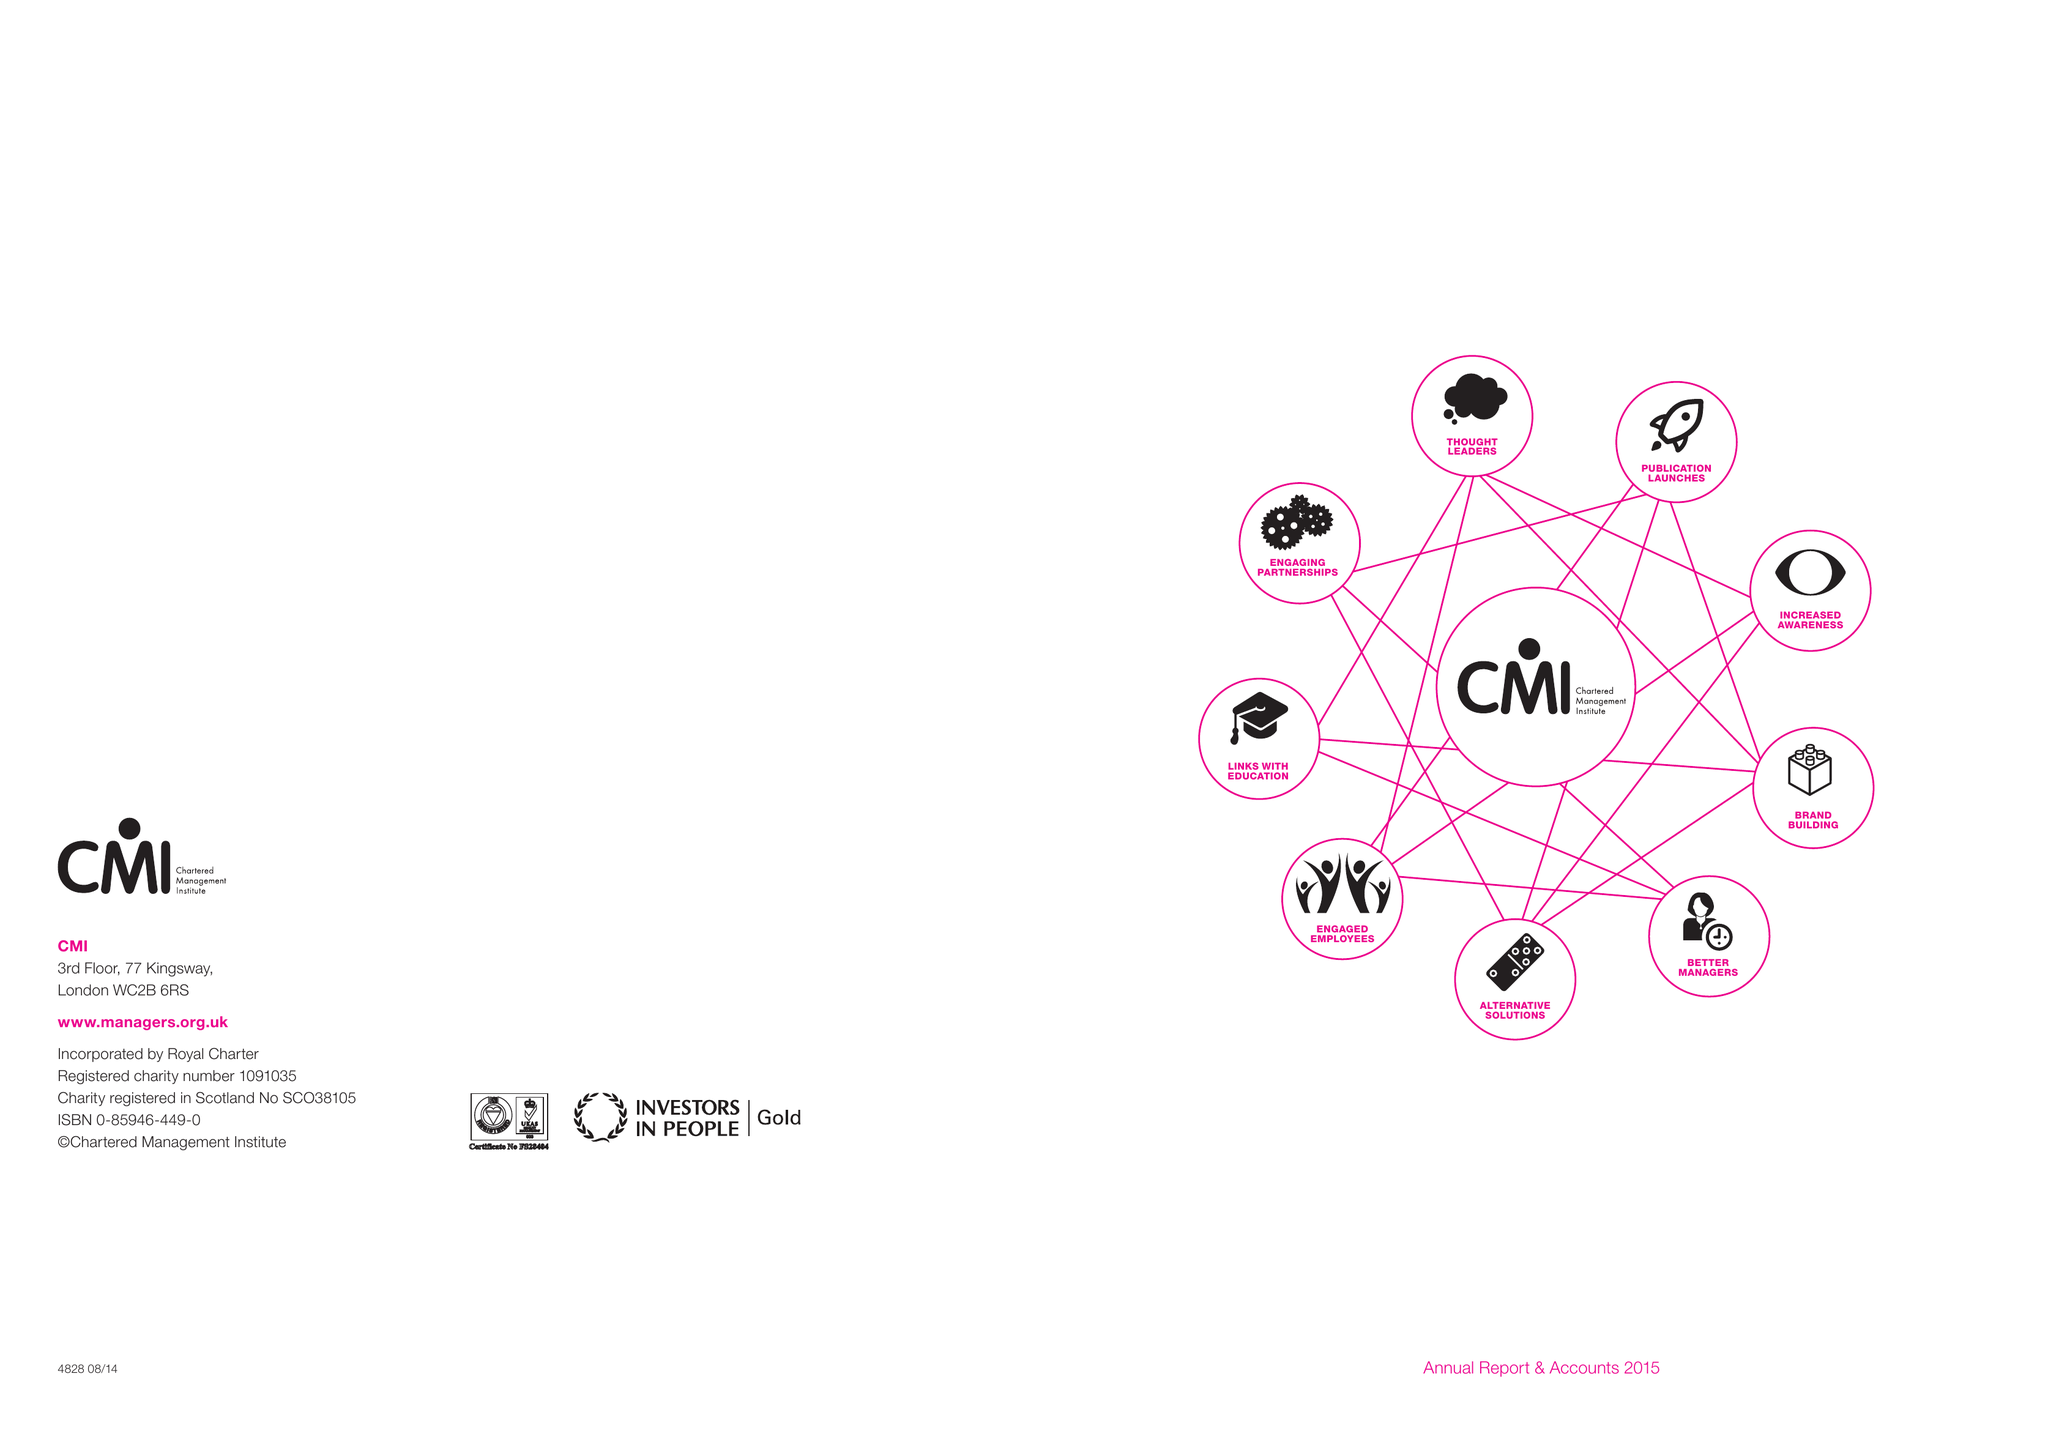What is the value for the charity_name?
Answer the question using a single word or phrase. Chartered Management Institute 